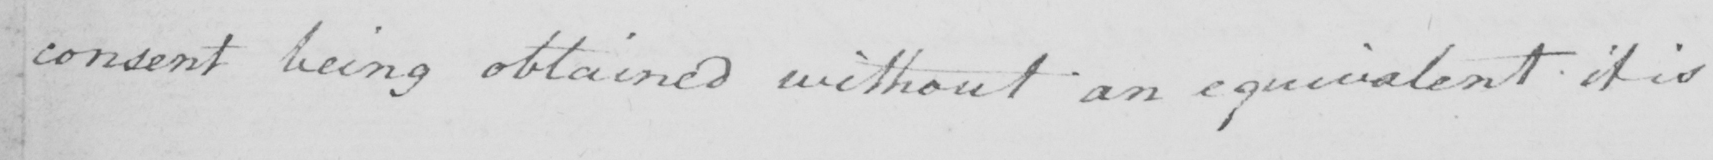What text is written in this handwritten line? consent being obtained without an equivalent it is 